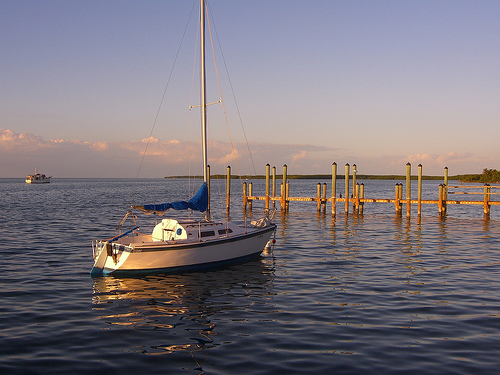<image>
Is the boat on the dock? No. The boat is not positioned on the dock. They may be near each other, but the boat is not supported by or resting on top of the dock. 